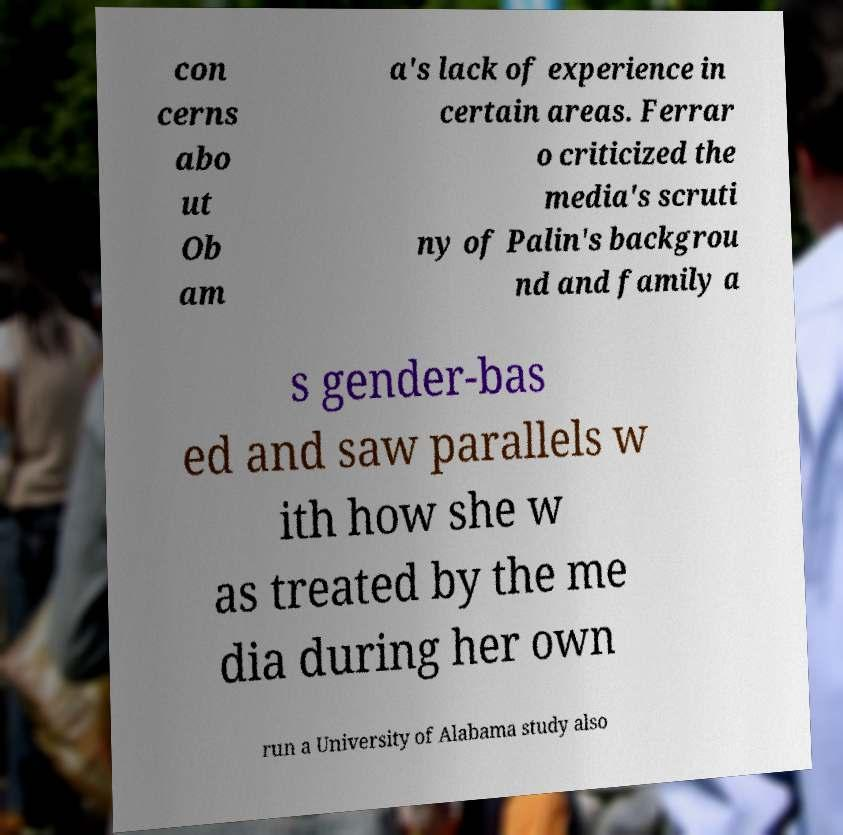Please identify and transcribe the text found in this image. con cerns abo ut Ob am a's lack of experience in certain areas. Ferrar o criticized the media's scruti ny of Palin's backgrou nd and family a s gender-bas ed and saw parallels w ith how she w as treated by the me dia during her own run a University of Alabama study also 